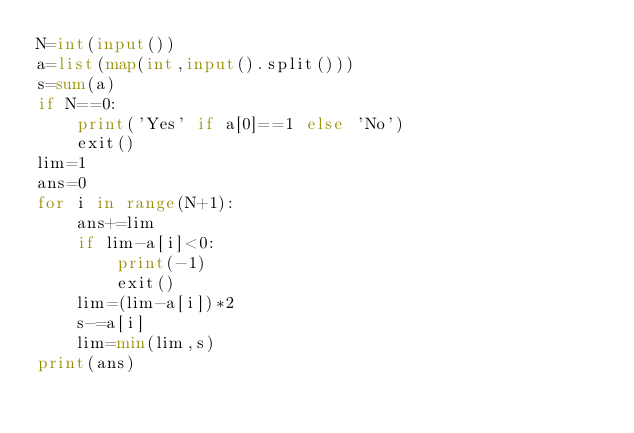<code> <loc_0><loc_0><loc_500><loc_500><_Python_>N=int(input())
a=list(map(int,input().split()))
s=sum(a)
if N==0:
    print('Yes' if a[0]==1 else 'No')
    exit()
lim=1
ans=0
for i in range(N+1):
    ans+=lim
    if lim-a[i]<0:
        print(-1)
        exit()
    lim=(lim-a[i])*2
    s-=a[i]
    lim=min(lim,s)
print(ans)</code> 